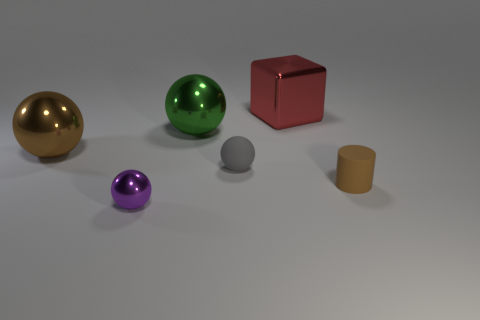Subtract all green balls. How many balls are left? 3 Add 2 big cyan metal cylinders. How many objects exist? 8 Subtract all gray spheres. How many spheres are left? 3 Subtract 1 spheres. How many spheres are left? 3 Subtract all gray spheres. Subtract all red cylinders. How many spheres are left? 3 Subtract all cubes. How many objects are left? 5 Subtract all rubber cylinders. Subtract all small red metallic spheres. How many objects are left? 5 Add 1 small gray balls. How many small gray balls are left? 2 Add 5 large green shiny cylinders. How many large green shiny cylinders exist? 5 Subtract 0 yellow spheres. How many objects are left? 6 